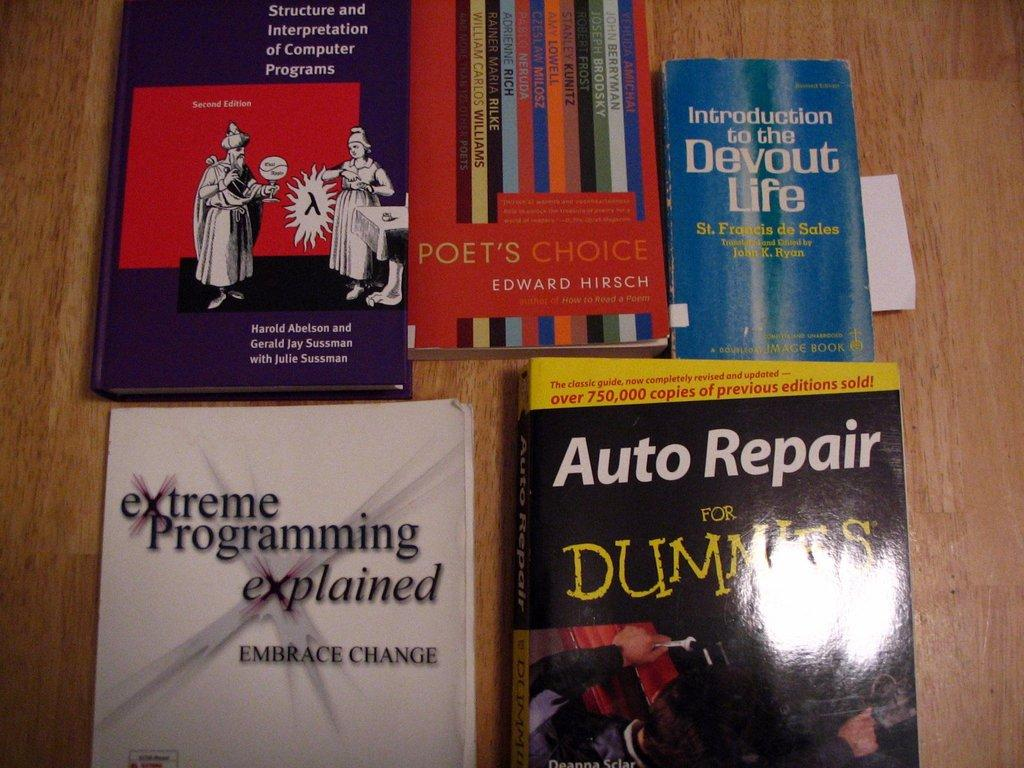<image>
Render a clear and concise summary of the photo. the words auto repair that is on a book 